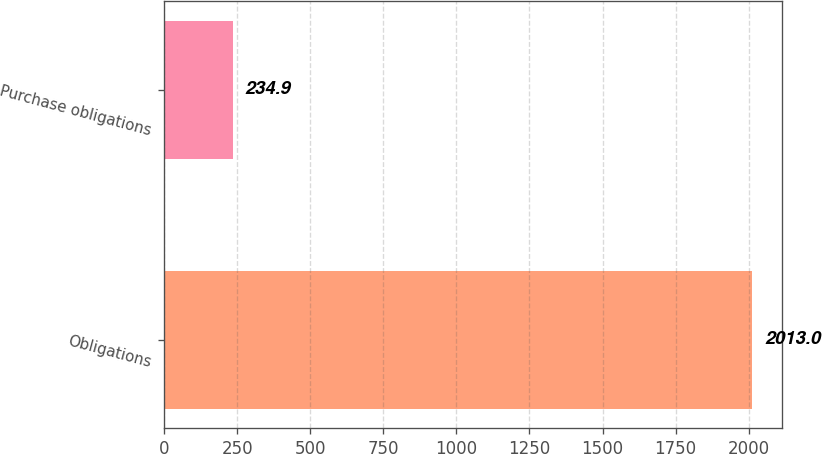<chart> <loc_0><loc_0><loc_500><loc_500><bar_chart><fcel>Obligations<fcel>Purchase obligations<nl><fcel>2013<fcel>234.9<nl></chart> 